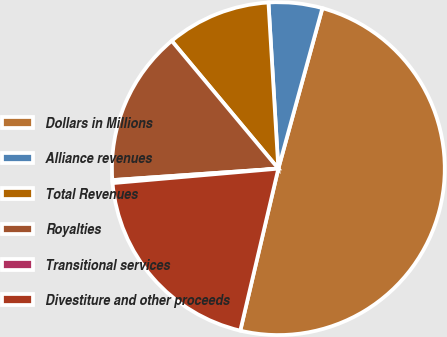<chart> <loc_0><loc_0><loc_500><loc_500><pie_chart><fcel>Dollars in Millions<fcel>Alliance revenues<fcel>Total Revenues<fcel>Royalties<fcel>Transitional services<fcel>Divestiture and other proceeds<nl><fcel>49.41%<fcel>5.21%<fcel>10.12%<fcel>15.03%<fcel>0.29%<fcel>19.94%<nl></chart> 